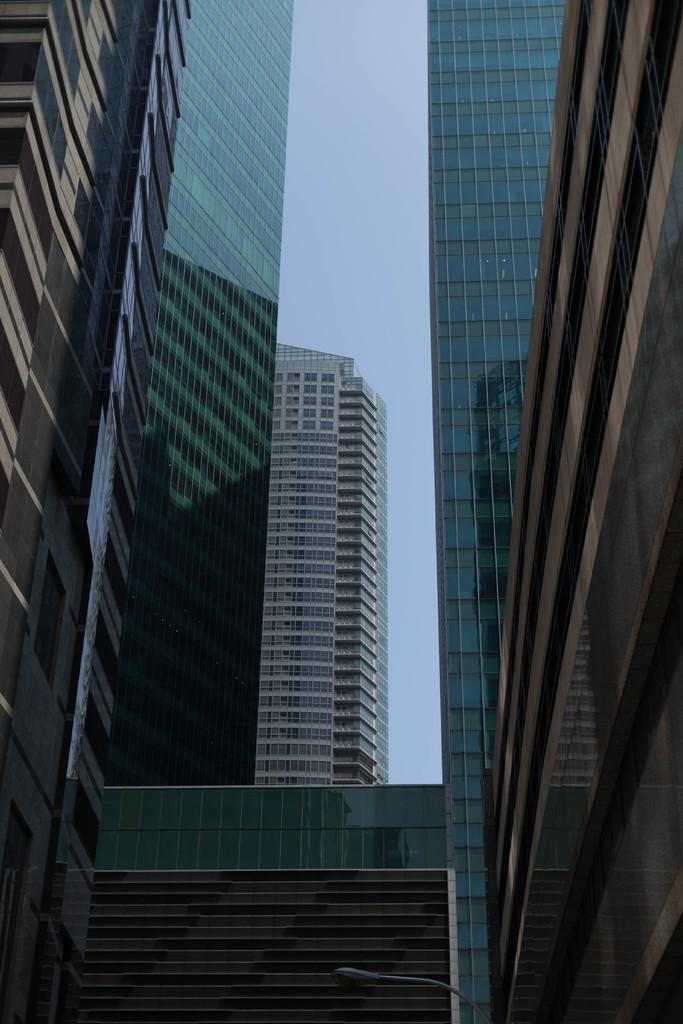What type of structures are present in the image? There are skyscrapers and buildings in the image. What can be seen at the top of the image? The sky is visible at the top of the image. What type of lamp is on the chair in the image? There is no lamp or chair present in the image. 